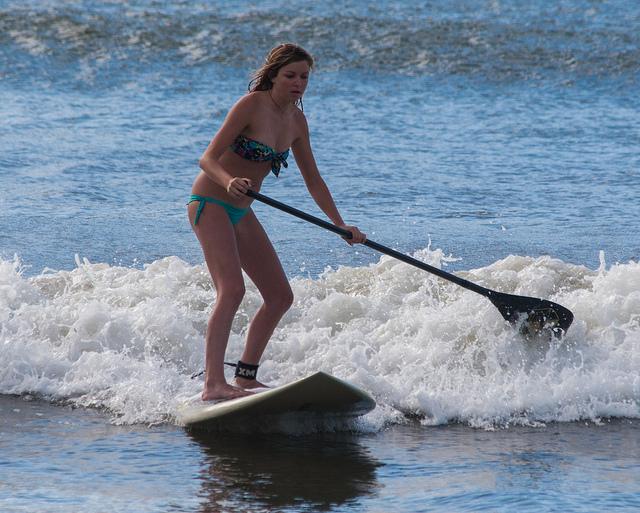Is the lady balanced?
Short answer required. Yes. Does the woman look happy?
Short answer required. Yes. Where is the leash for the board?
Keep it brief. Ankle. Is her hair wet?
Quick response, please. Yes. 